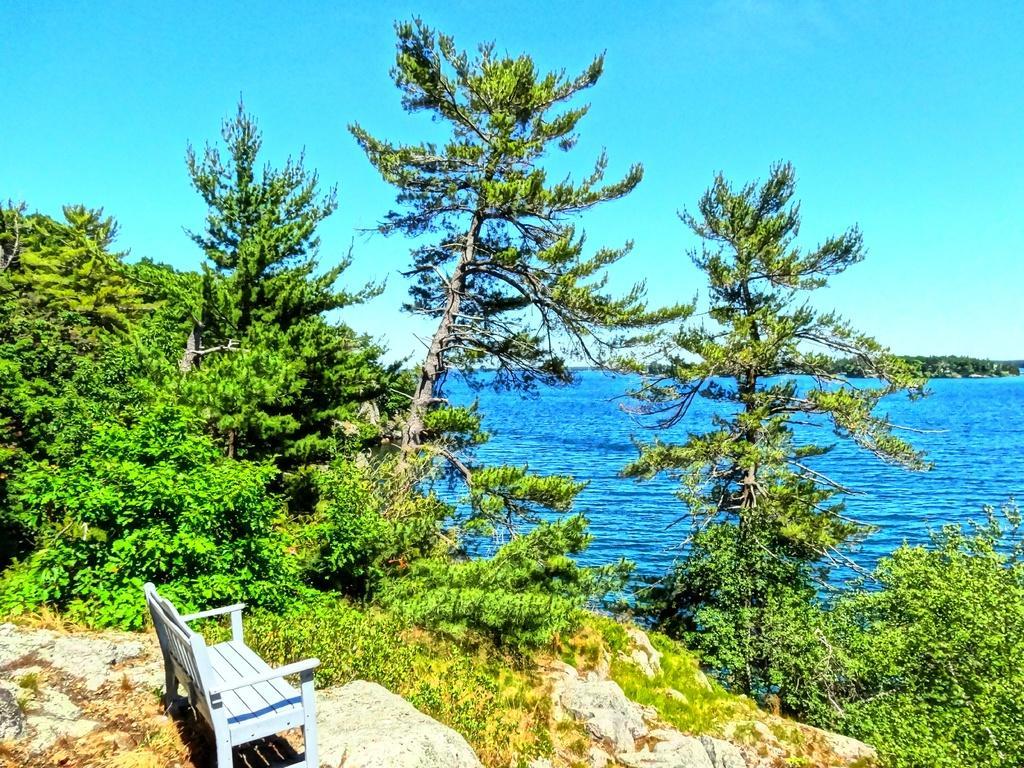How would you summarize this image in a sentence or two? At the bottom of the picture, we see a bench and rocks. Beside that, there are trees. We see water. There are trees in the background. At the top of the picture, we see the sky, which is blue in color. 